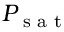Convert formula to latex. <formula><loc_0><loc_0><loc_500><loc_500>P _ { s a t }</formula> 